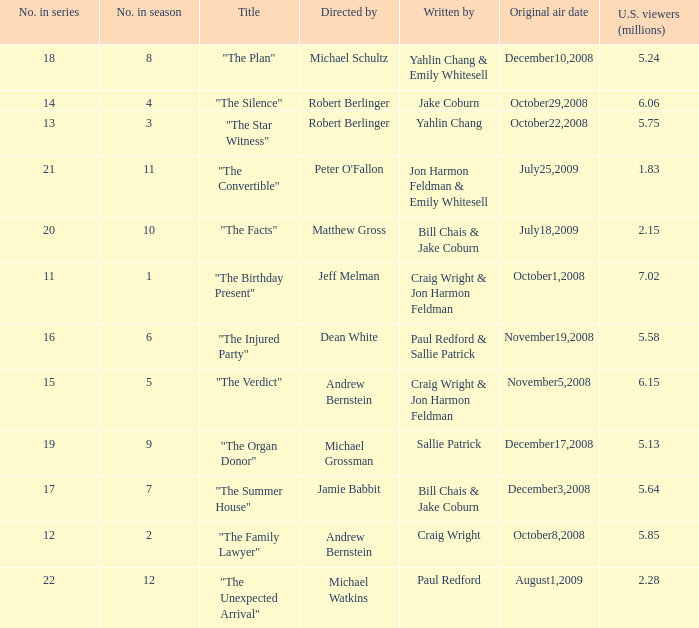Who wrote the episode that received 1.83 million U.S. viewers? Jon Harmon Feldman & Emily Whitesell. 